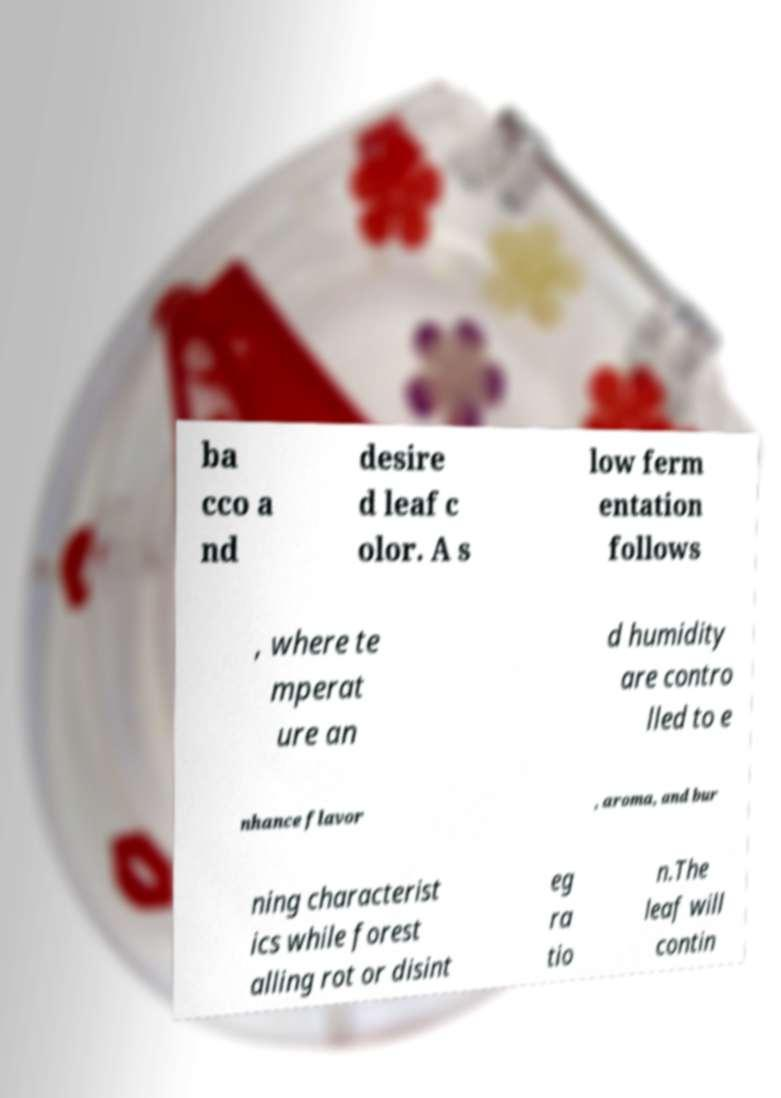Please identify and transcribe the text found in this image. ba cco a nd desire d leaf c olor. A s low ferm entation follows , where te mperat ure an d humidity are contro lled to e nhance flavor , aroma, and bur ning characterist ics while forest alling rot or disint eg ra tio n.The leaf will contin 